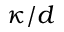Convert formula to latex. <formula><loc_0><loc_0><loc_500><loc_500>\kappa / d</formula> 